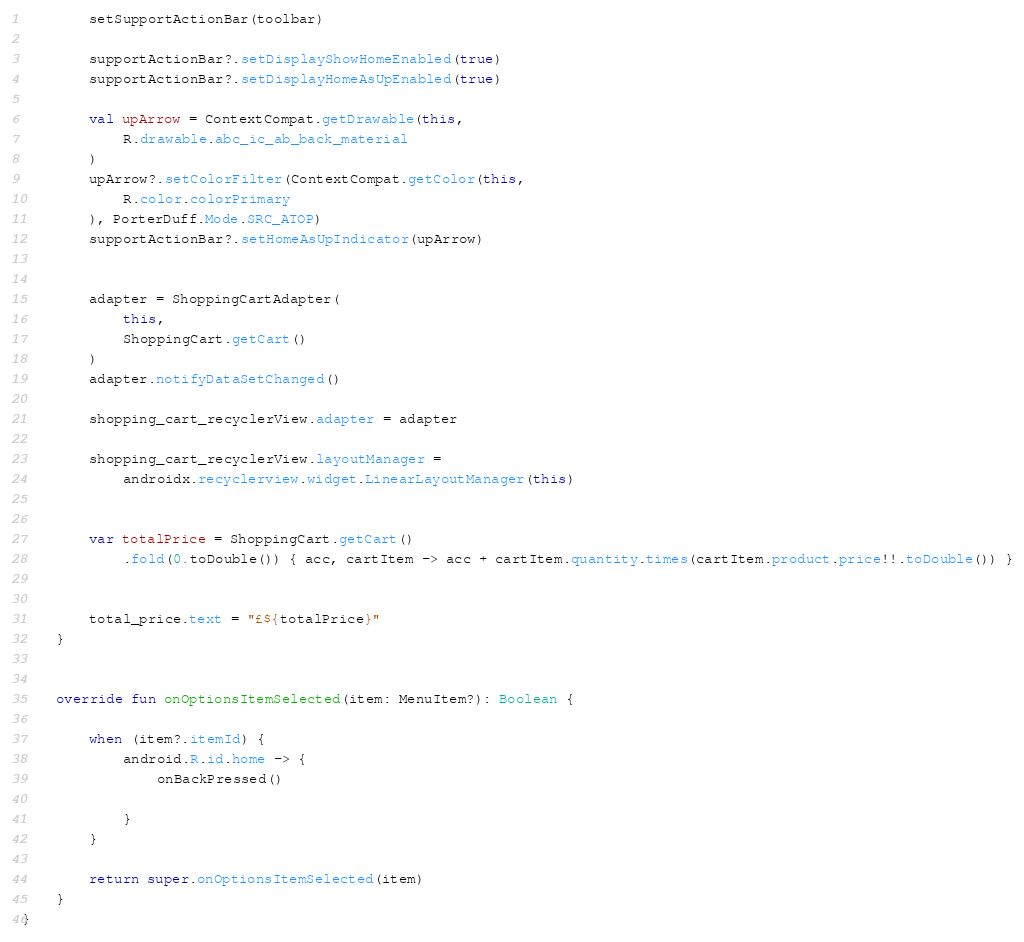<code> <loc_0><loc_0><loc_500><loc_500><_Kotlin_>        setSupportActionBar(toolbar)

        supportActionBar?.setDisplayShowHomeEnabled(true)
        supportActionBar?.setDisplayHomeAsUpEnabled(true)

        val upArrow = ContextCompat.getDrawable(this,
            R.drawable.abc_ic_ab_back_material
        )
        upArrow?.setColorFilter(ContextCompat.getColor(this,
            R.color.colorPrimary
        ), PorterDuff.Mode.SRC_ATOP)
        supportActionBar?.setHomeAsUpIndicator(upArrow)


        adapter = ShoppingCartAdapter(
            this,
            ShoppingCart.getCart()
        )
        adapter.notifyDataSetChanged()

        shopping_cart_recyclerView.adapter = adapter

        shopping_cart_recyclerView.layoutManager =
            androidx.recyclerview.widget.LinearLayoutManager(this)


        var totalPrice = ShoppingCart.getCart()
            .fold(0.toDouble()) { acc, cartItem -> acc + cartItem.quantity.times(cartItem.product.price!!.toDouble()) }


        total_price.text = "£${totalPrice}"
    }


    override fun onOptionsItemSelected(item: MenuItem?): Boolean {

        when (item?.itemId) {
            android.R.id.home -> {
                onBackPressed()

            }
        }

        return super.onOptionsItemSelected(item)
    }
}
</code> 